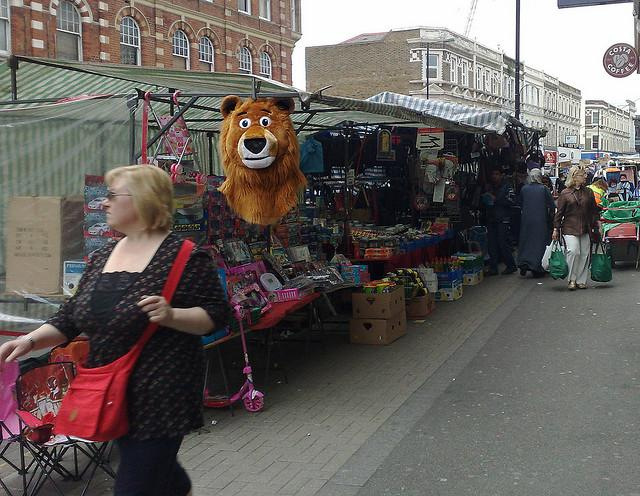Why are there stalls with products outside? selling products 